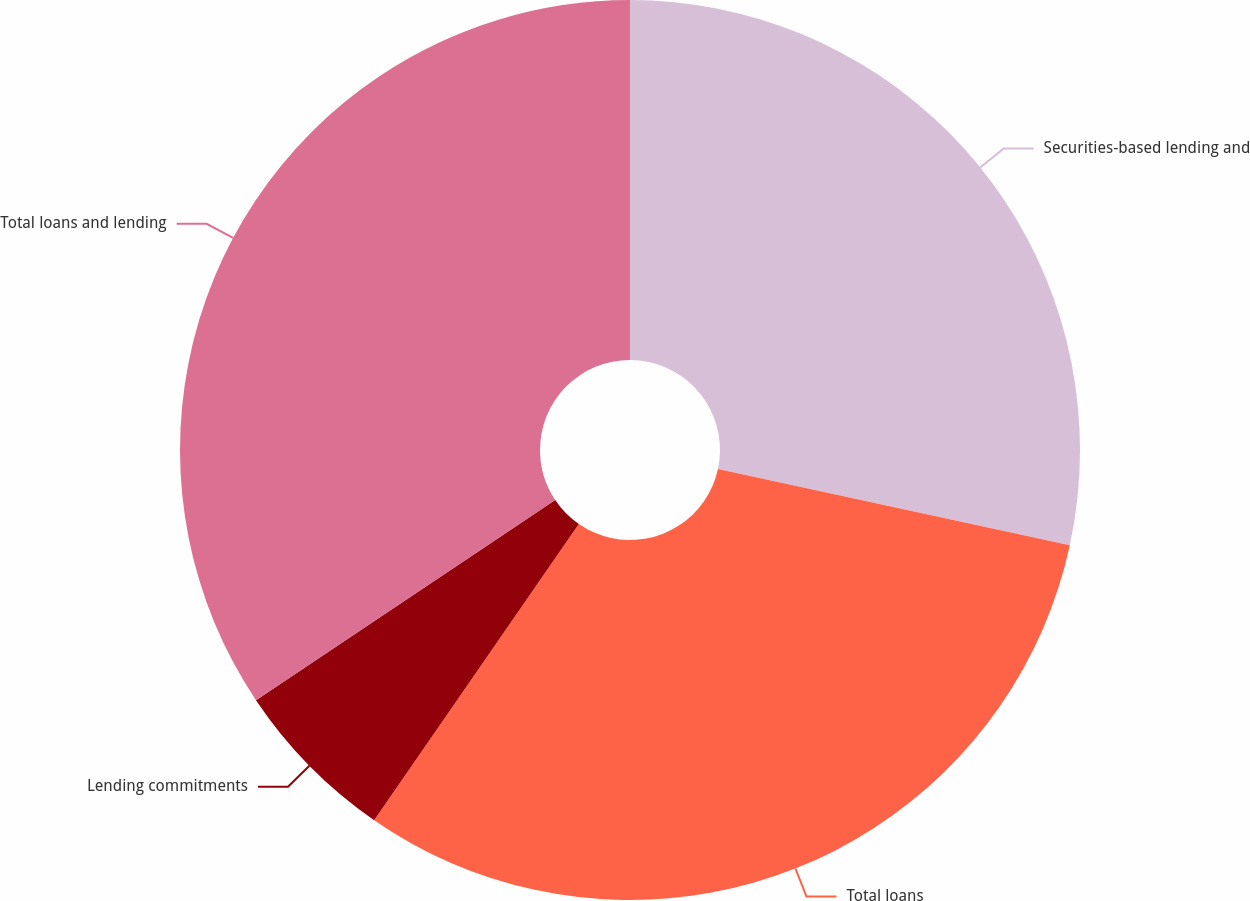Convert chart to OTSL. <chart><loc_0><loc_0><loc_500><loc_500><pie_chart><fcel>Securities-based lending and<fcel>Total loans<fcel>Lending commitments<fcel>Total loans and lending<nl><fcel>28.39%<fcel>31.23%<fcel>5.99%<fcel>34.38%<nl></chart> 